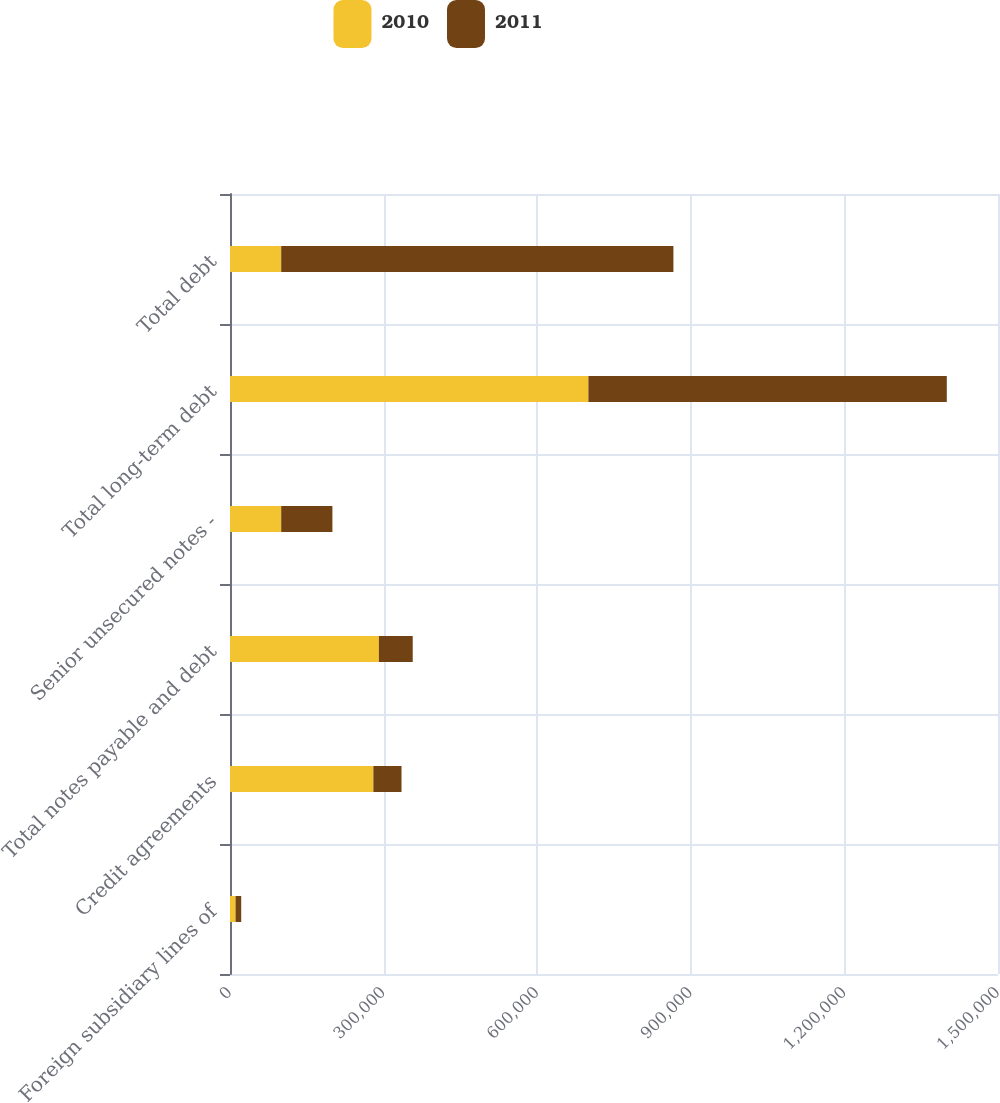Convert chart. <chart><loc_0><loc_0><loc_500><loc_500><stacked_bar_chart><ecel><fcel>Foreign subsidiary lines of<fcel>Credit agreements<fcel>Total notes payable and debt<fcel>Senior unsecured notes -<fcel>Total long-term debt<fcel>Total debt<nl><fcel>2010<fcel>10832<fcel>280000<fcel>290832<fcel>100000<fcel>700000<fcel>100000<nl><fcel>2011<fcel>11055<fcel>55000<fcel>66055<fcel>100000<fcel>700000<fcel>766055<nl></chart> 